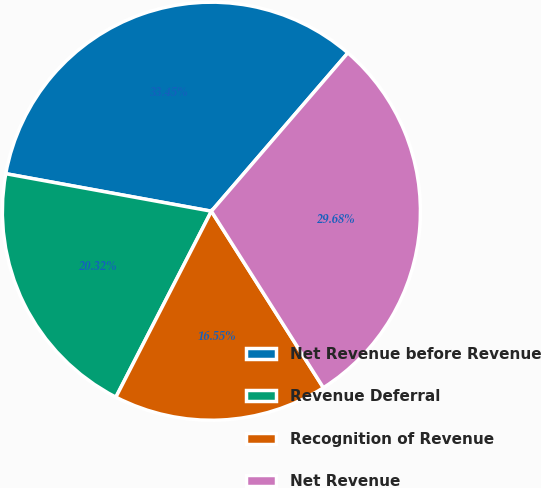Convert chart to OTSL. <chart><loc_0><loc_0><loc_500><loc_500><pie_chart><fcel>Net Revenue before Revenue<fcel>Revenue Deferral<fcel>Recognition of Revenue<fcel>Net Revenue<nl><fcel>33.45%<fcel>20.32%<fcel>16.55%<fcel>29.68%<nl></chart> 